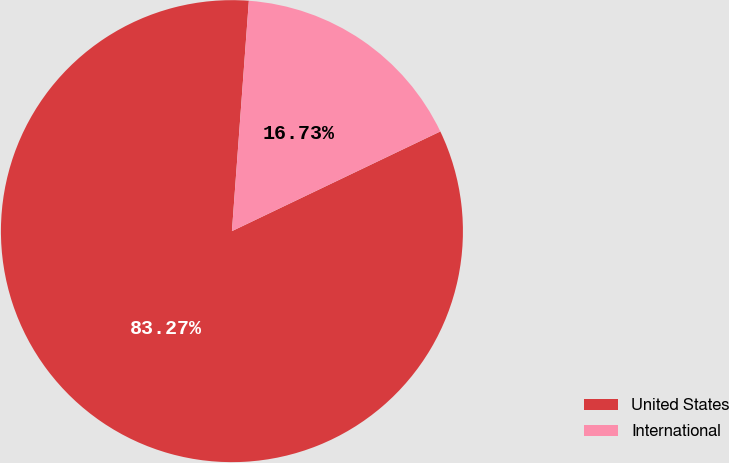Convert chart. <chart><loc_0><loc_0><loc_500><loc_500><pie_chart><fcel>United States<fcel>International<nl><fcel>83.27%<fcel>16.73%<nl></chart> 